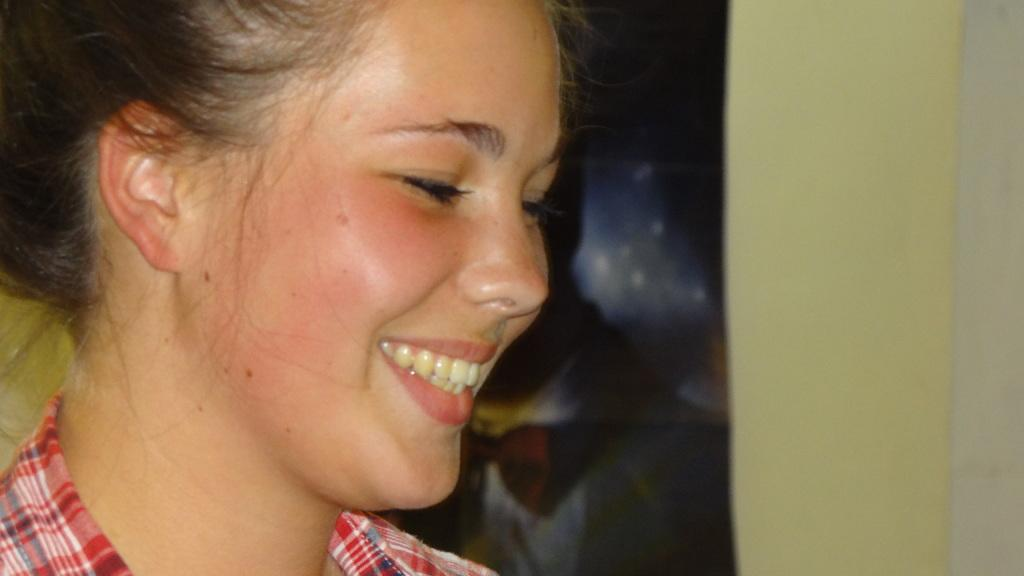Who is present in the image? There is a girl in the image. What is the girl's expression in the image? The girl is smiling in the image. What organization does the girl belong to in the image? There is no information about any organization in the image; it only shows a girl smiling. 